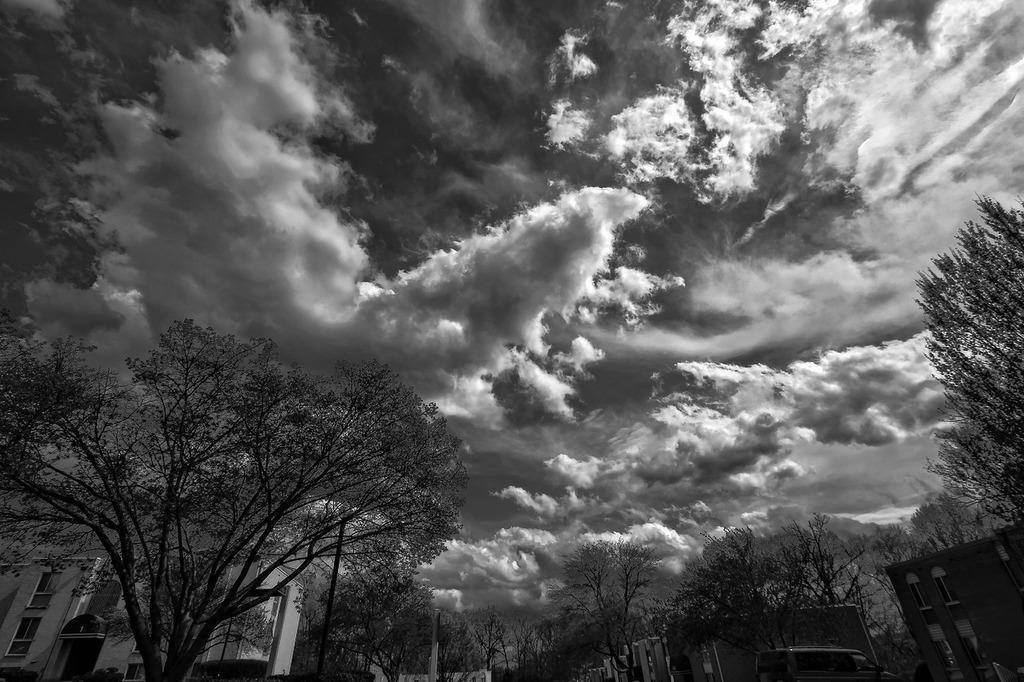In one or two sentences, can you explain what this image depicts? In this picture we can see trees at the bottom, on the left side there is a building, we can see the sky and clouds at the top of the picture, it is a black and white image. 